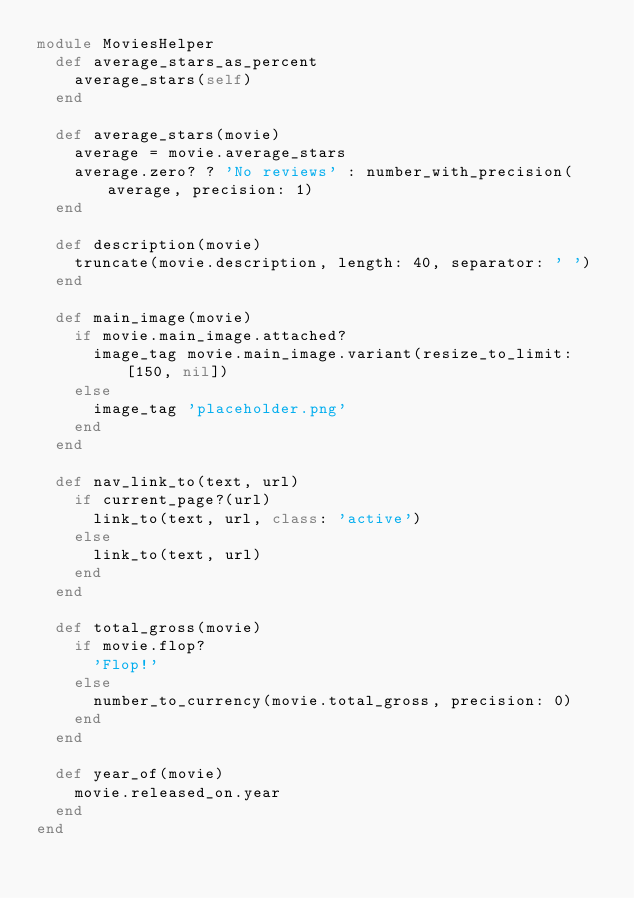<code> <loc_0><loc_0><loc_500><loc_500><_Ruby_>module MoviesHelper
  def average_stars_as_percent
    average_stars(self)
  end

  def average_stars(movie)
    average = movie.average_stars
    average.zero? ? 'No reviews' : number_with_precision(average, precision: 1)
  end

  def description(movie)
    truncate(movie.description, length: 40, separator: ' ')
  end

  def main_image(movie)
    if movie.main_image.attached?
      image_tag movie.main_image.variant(resize_to_limit: [150, nil])
    else
      image_tag 'placeholder.png'
    end
  end

  def nav_link_to(text, url)
    if current_page?(url)
      link_to(text, url, class: 'active')
    else
      link_to(text, url)
    end
  end

  def total_gross(movie)
    if movie.flop?
      'Flop!'
    else
      number_to_currency(movie.total_gross, precision: 0)
    end
  end

  def year_of(movie)
    movie.released_on.year
  end
end
</code> 